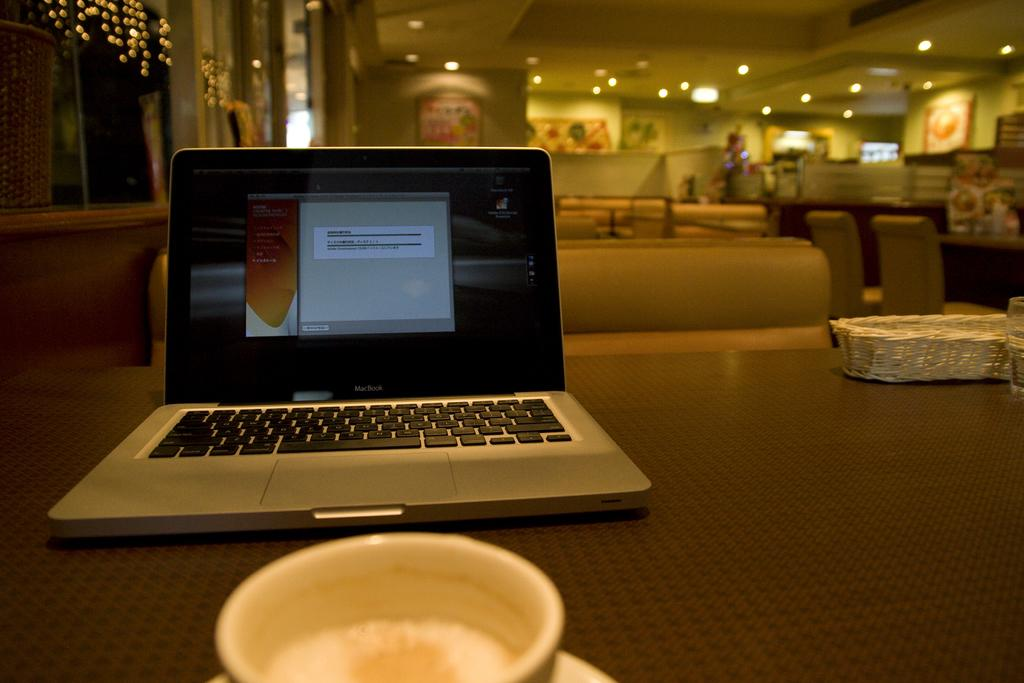What electronic device is visible in the image? There is a laptop in the image. What beverage container is present in the image? There is a tea cup in the image. Where are the laptop and tea cup located? Both the laptop and the tea cup are on a table. What can be seen providing illumination in the image? There are lights visible in the image. What type of furniture is present in the image? There are chairs in the image. What type of screw is holding the laptop together in the image? There is no visible screw holding the laptop together in the image. What advice does the mother give to her child in the image? There is no mother or child present in the image, and therefore no such interaction can be observed. What type of verse is written on the table in the image? There is no verse written on the table in the image. 